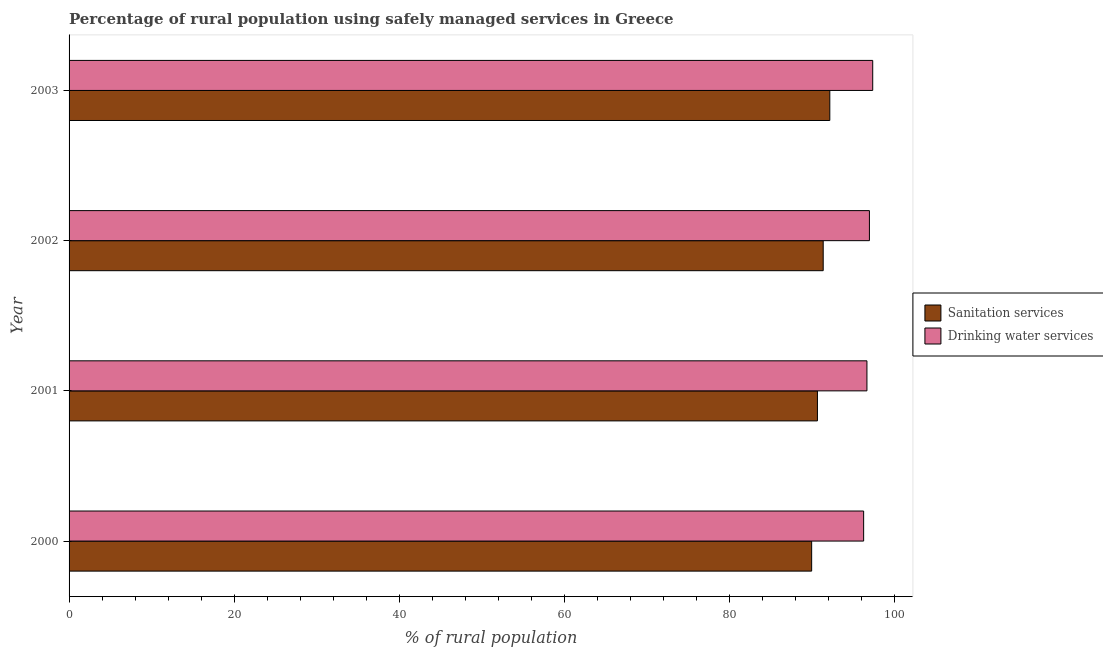Are the number of bars per tick equal to the number of legend labels?
Keep it short and to the point. Yes. Are the number of bars on each tick of the Y-axis equal?
Provide a succinct answer. Yes. How many bars are there on the 3rd tick from the bottom?
Your response must be concise. 2. What is the label of the 1st group of bars from the top?
Offer a terse response. 2003. What is the percentage of rural population who used sanitation services in 2001?
Offer a very short reply. 90.7. Across all years, what is the maximum percentage of rural population who used sanitation services?
Give a very brief answer. 92.2. Across all years, what is the minimum percentage of rural population who used drinking water services?
Ensure brevity in your answer.  96.3. In which year was the percentage of rural population who used sanitation services maximum?
Your answer should be very brief. 2003. In which year was the percentage of rural population who used sanitation services minimum?
Make the answer very short. 2000. What is the total percentage of rural population who used sanitation services in the graph?
Give a very brief answer. 364.3. What is the difference between the percentage of rural population who used drinking water services in 2002 and that in 2003?
Offer a very short reply. -0.4. What is the difference between the percentage of rural population who used drinking water services in 2002 and the percentage of rural population who used sanitation services in 2001?
Provide a short and direct response. 6.3. What is the average percentage of rural population who used drinking water services per year?
Keep it short and to the point. 96.85. In the year 2003, what is the difference between the percentage of rural population who used drinking water services and percentage of rural population who used sanitation services?
Provide a short and direct response. 5.2. In how many years, is the percentage of rural population who used drinking water services greater than 96 %?
Ensure brevity in your answer.  4. Is the percentage of rural population who used sanitation services in 2001 less than that in 2003?
Keep it short and to the point. Yes. What does the 2nd bar from the top in 2002 represents?
Offer a very short reply. Sanitation services. What does the 2nd bar from the bottom in 2003 represents?
Your response must be concise. Drinking water services. How many bars are there?
Keep it short and to the point. 8. Are all the bars in the graph horizontal?
Make the answer very short. Yes. Where does the legend appear in the graph?
Your answer should be compact. Center right. How many legend labels are there?
Offer a very short reply. 2. How are the legend labels stacked?
Ensure brevity in your answer.  Vertical. What is the title of the graph?
Offer a terse response. Percentage of rural population using safely managed services in Greece. Does "Electricity" appear as one of the legend labels in the graph?
Provide a short and direct response. No. What is the label or title of the X-axis?
Ensure brevity in your answer.  % of rural population. What is the % of rural population of Sanitation services in 2000?
Give a very brief answer. 90. What is the % of rural population in Drinking water services in 2000?
Offer a very short reply. 96.3. What is the % of rural population in Sanitation services in 2001?
Your answer should be very brief. 90.7. What is the % of rural population in Drinking water services in 2001?
Offer a terse response. 96.7. What is the % of rural population of Sanitation services in 2002?
Your response must be concise. 91.4. What is the % of rural population of Drinking water services in 2002?
Keep it short and to the point. 97. What is the % of rural population of Sanitation services in 2003?
Give a very brief answer. 92.2. What is the % of rural population of Drinking water services in 2003?
Ensure brevity in your answer.  97.4. Across all years, what is the maximum % of rural population in Sanitation services?
Keep it short and to the point. 92.2. Across all years, what is the maximum % of rural population in Drinking water services?
Keep it short and to the point. 97.4. Across all years, what is the minimum % of rural population of Sanitation services?
Make the answer very short. 90. Across all years, what is the minimum % of rural population in Drinking water services?
Keep it short and to the point. 96.3. What is the total % of rural population in Sanitation services in the graph?
Offer a terse response. 364.3. What is the total % of rural population in Drinking water services in the graph?
Give a very brief answer. 387.4. What is the difference between the % of rural population of Sanitation services in 2000 and that in 2001?
Ensure brevity in your answer.  -0.7. What is the difference between the % of rural population in Sanitation services in 2000 and that in 2003?
Offer a terse response. -2.2. What is the difference between the % of rural population in Drinking water services in 2000 and that in 2003?
Provide a short and direct response. -1.1. What is the difference between the % of rural population of Drinking water services in 2001 and that in 2002?
Your response must be concise. -0.3. What is the difference between the % of rural population in Sanitation services in 2001 and that in 2003?
Your answer should be very brief. -1.5. What is the difference between the % of rural population of Drinking water services in 2001 and that in 2003?
Offer a terse response. -0.7. What is the difference between the % of rural population in Sanitation services in 2002 and that in 2003?
Offer a terse response. -0.8. What is the difference between the % of rural population of Drinking water services in 2002 and that in 2003?
Give a very brief answer. -0.4. What is the difference between the % of rural population in Sanitation services in 2001 and the % of rural population in Drinking water services in 2003?
Make the answer very short. -6.7. What is the average % of rural population in Sanitation services per year?
Offer a very short reply. 91.08. What is the average % of rural population of Drinking water services per year?
Offer a terse response. 96.85. In the year 2002, what is the difference between the % of rural population in Sanitation services and % of rural population in Drinking water services?
Your answer should be compact. -5.6. What is the ratio of the % of rural population in Sanitation services in 2000 to that in 2001?
Make the answer very short. 0.99. What is the ratio of the % of rural population of Drinking water services in 2000 to that in 2001?
Give a very brief answer. 1. What is the ratio of the % of rural population of Sanitation services in 2000 to that in 2002?
Keep it short and to the point. 0.98. What is the ratio of the % of rural population in Drinking water services in 2000 to that in 2002?
Your response must be concise. 0.99. What is the ratio of the % of rural population of Sanitation services in 2000 to that in 2003?
Offer a terse response. 0.98. What is the ratio of the % of rural population in Drinking water services in 2000 to that in 2003?
Offer a very short reply. 0.99. What is the ratio of the % of rural population of Sanitation services in 2001 to that in 2002?
Provide a short and direct response. 0.99. What is the ratio of the % of rural population of Drinking water services in 2001 to that in 2002?
Your answer should be compact. 1. What is the ratio of the % of rural population in Sanitation services in 2001 to that in 2003?
Your response must be concise. 0.98. What is the ratio of the % of rural population in Sanitation services in 2002 to that in 2003?
Offer a terse response. 0.99. What is the difference between the highest and the second highest % of rural population of Sanitation services?
Provide a succinct answer. 0.8. What is the difference between the highest and the lowest % of rural population in Sanitation services?
Provide a succinct answer. 2.2. What is the difference between the highest and the lowest % of rural population in Drinking water services?
Keep it short and to the point. 1.1. 